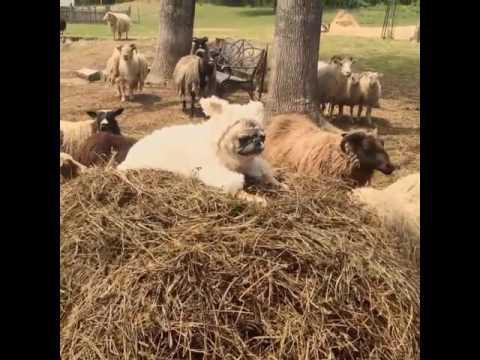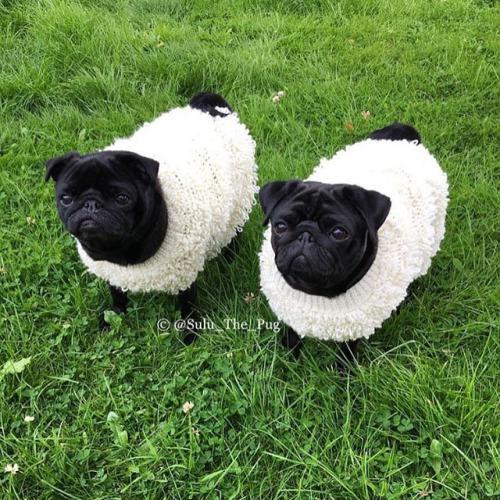The first image is the image on the left, the second image is the image on the right. Evaluate the accuracy of this statement regarding the images: "Only one of the images shows a dog wearing animal-themed attire.". Is it true? Answer yes or no. No. The first image is the image on the left, the second image is the image on the right. Examine the images to the left and right. Is the description "A dog is shown near some sheep." accurate? Answer yes or no. Yes. 